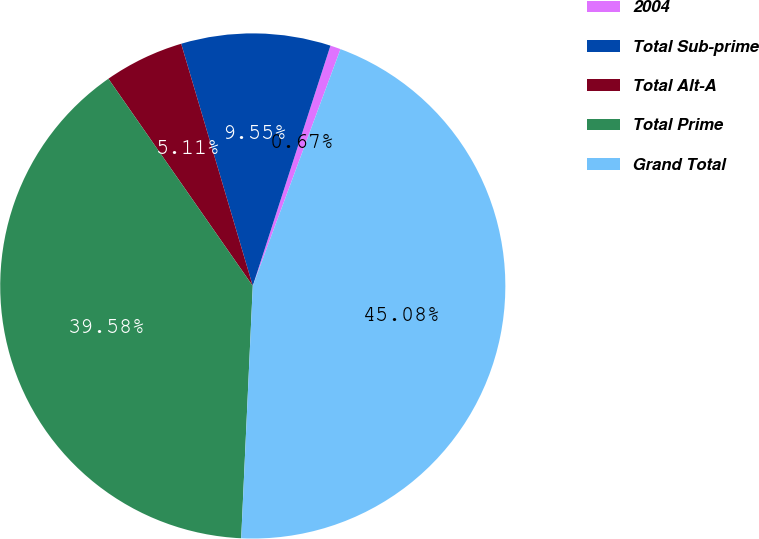Convert chart to OTSL. <chart><loc_0><loc_0><loc_500><loc_500><pie_chart><fcel>2004<fcel>Total Sub-prime<fcel>Total Alt-A<fcel>Total Prime<fcel>Grand Total<nl><fcel>0.67%<fcel>9.55%<fcel>5.11%<fcel>39.58%<fcel>45.08%<nl></chart> 